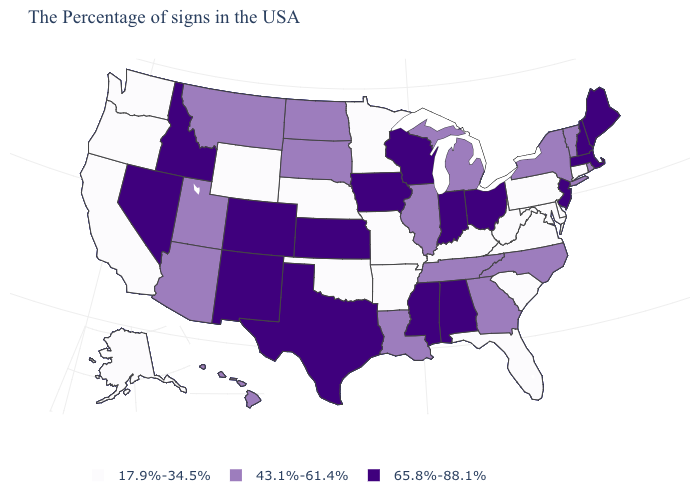Name the states that have a value in the range 17.9%-34.5%?
Quick response, please. Connecticut, Delaware, Maryland, Pennsylvania, Virginia, South Carolina, West Virginia, Florida, Kentucky, Missouri, Arkansas, Minnesota, Nebraska, Oklahoma, Wyoming, California, Washington, Oregon, Alaska. Does the first symbol in the legend represent the smallest category?
Keep it brief. Yes. What is the value of Connecticut?
Answer briefly. 17.9%-34.5%. Name the states that have a value in the range 65.8%-88.1%?
Answer briefly. Maine, Massachusetts, New Hampshire, New Jersey, Ohio, Indiana, Alabama, Wisconsin, Mississippi, Iowa, Kansas, Texas, Colorado, New Mexico, Idaho, Nevada. What is the value of Washington?
Write a very short answer. 17.9%-34.5%. Among the states that border Pennsylvania , which have the highest value?
Answer briefly. New Jersey, Ohio. What is the value of West Virginia?
Be succinct. 17.9%-34.5%. What is the value of New Hampshire?
Write a very short answer. 65.8%-88.1%. Name the states that have a value in the range 43.1%-61.4%?
Keep it brief. Rhode Island, Vermont, New York, North Carolina, Georgia, Michigan, Tennessee, Illinois, Louisiana, South Dakota, North Dakota, Utah, Montana, Arizona, Hawaii. Name the states that have a value in the range 17.9%-34.5%?
Be succinct. Connecticut, Delaware, Maryland, Pennsylvania, Virginia, South Carolina, West Virginia, Florida, Kentucky, Missouri, Arkansas, Minnesota, Nebraska, Oklahoma, Wyoming, California, Washington, Oregon, Alaska. Among the states that border Michigan , which have the lowest value?
Give a very brief answer. Ohio, Indiana, Wisconsin. Does Delaware have the highest value in the South?
Short answer required. No. Does New York have the highest value in the Northeast?
Be succinct. No. Which states have the lowest value in the USA?
Give a very brief answer. Connecticut, Delaware, Maryland, Pennsylvania, Virginia, South Carolina, West Virginia, Florida, Kentucky, Missouri, Arkansas, Minnesota, Nebraska, Oklahoma, Wyoming, California, Washington, Oregon, Alaska. Does Idaho have the highest value in the West?
Write a very short answer. Yes. 